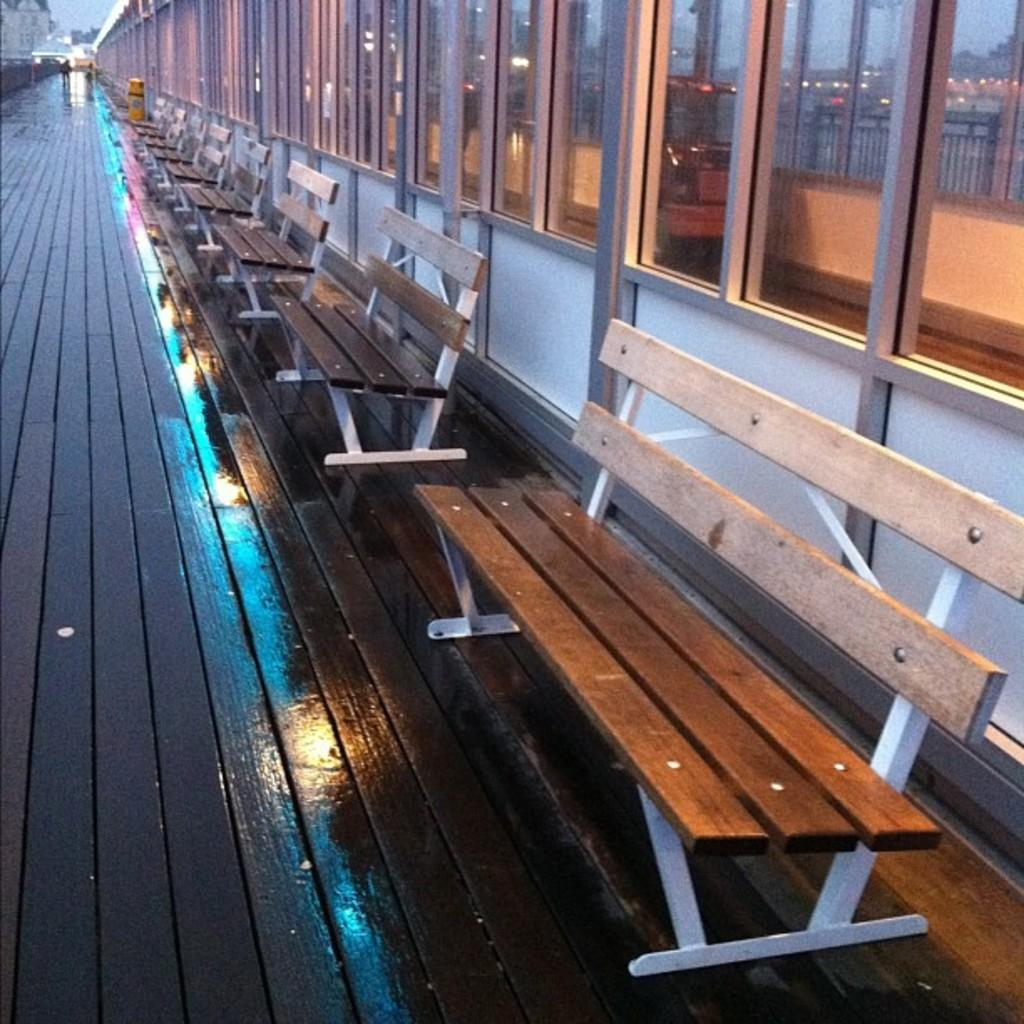What objects are located in the middle of the picture? There are benches in the middle of the picture. What type of material is used for the windows behind the benches? The windows behind the benches are made of glass. Where is the pump located in the image? There is no pump present in the image. What type of ornament is hanging from the benches in the image? There is no ornament hanging from the benches in the image. 